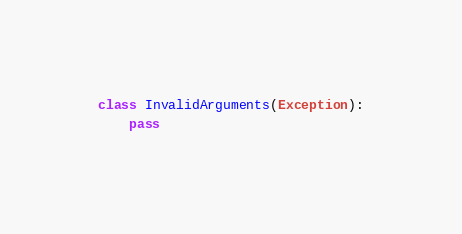Convert code to text. <code><loc_0><loc_0><loc_500><loc_500><_Python_>
class InvalidArguments(Exception):
    pass
</code> 